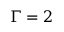Convert formula to latex. <formula><loc_0><loc_0><loc_500><loc_500>\Gamma = 2</formula> 